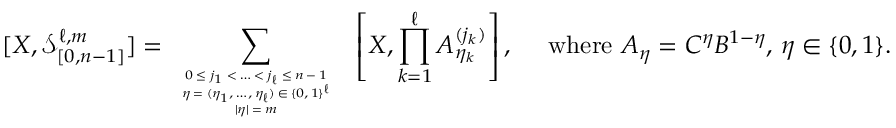<formula> <loc_0><loc_0><loc_500><loc_500>[ X , \mathcal { S } _ { [ 0 , n - 1 ] } ^ { \ell , m } ] = \sum _ { \begin{array} { c } { 0 \leq j _ { 1 } < \dots < j _ { \ell } \leq n - 1 } \\ { \eta = ( \eta _ { 1 } , \dots , \eta _ { \ell } ) \in \{ 0 , 1 \} ^ { \ell } } \\ { | \eta | = m } \end{array} } \, \left [ X , \prod _ { k = 1 } ^ { \ell } A _ { \eta _ { k } } ^ { ( j _ { k } ) } \right ] , \quad w h e r e A _ { \eta } = C ^ { \eta } B ^ { 1 - \eta } , \, \eta \in \{ 0 , 1 \} .</formula> 